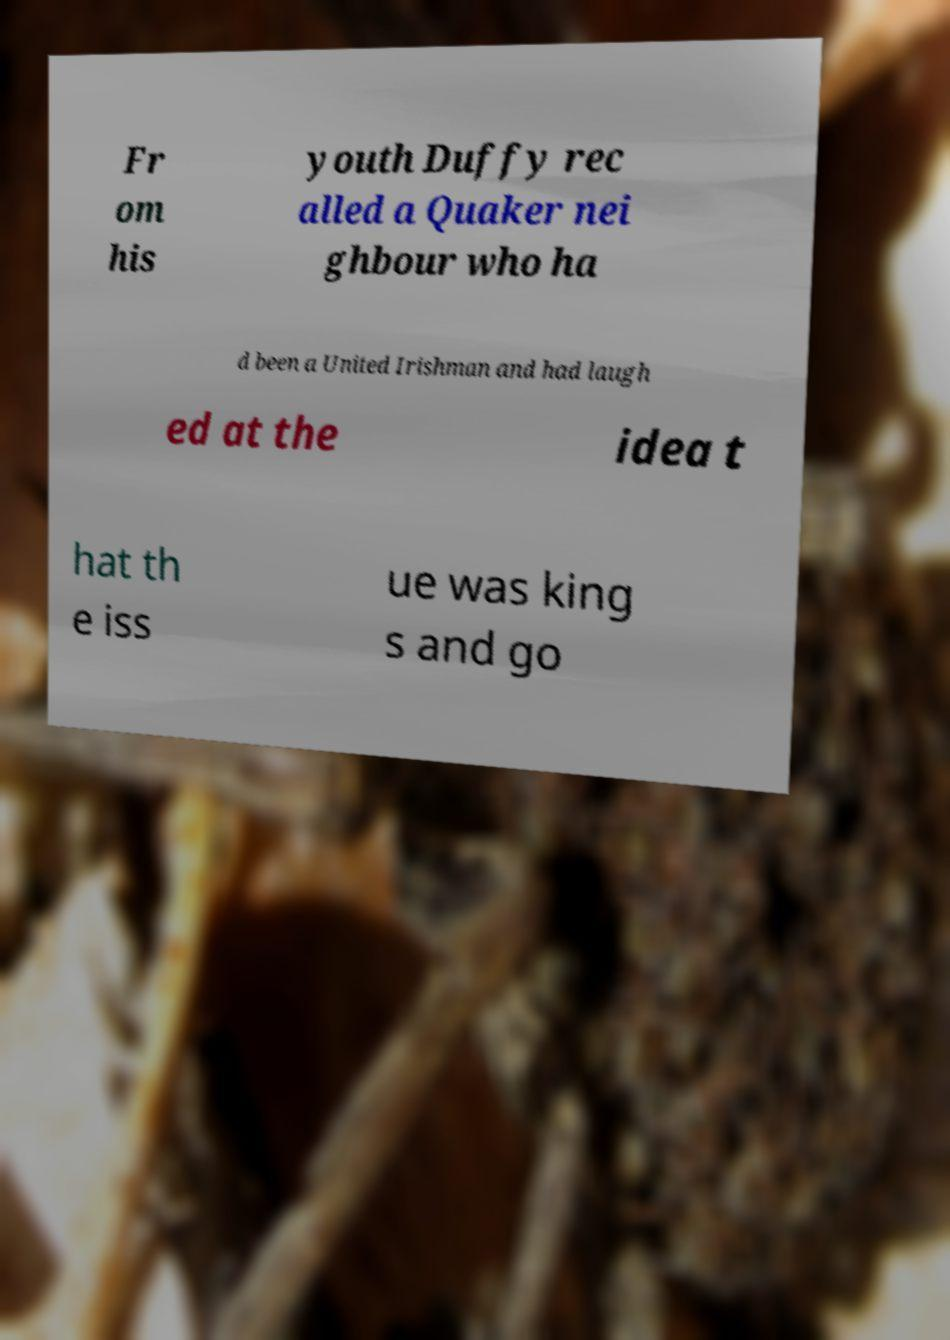There's text embedded in this image that I need extracted. Can you transcribe it verbatim? Fr om his youth Duffy rec alled a Quaker nei ghbour who ha d been a United Irishman and had laugh ed at the idea t hat th e iss ue was king s and go 